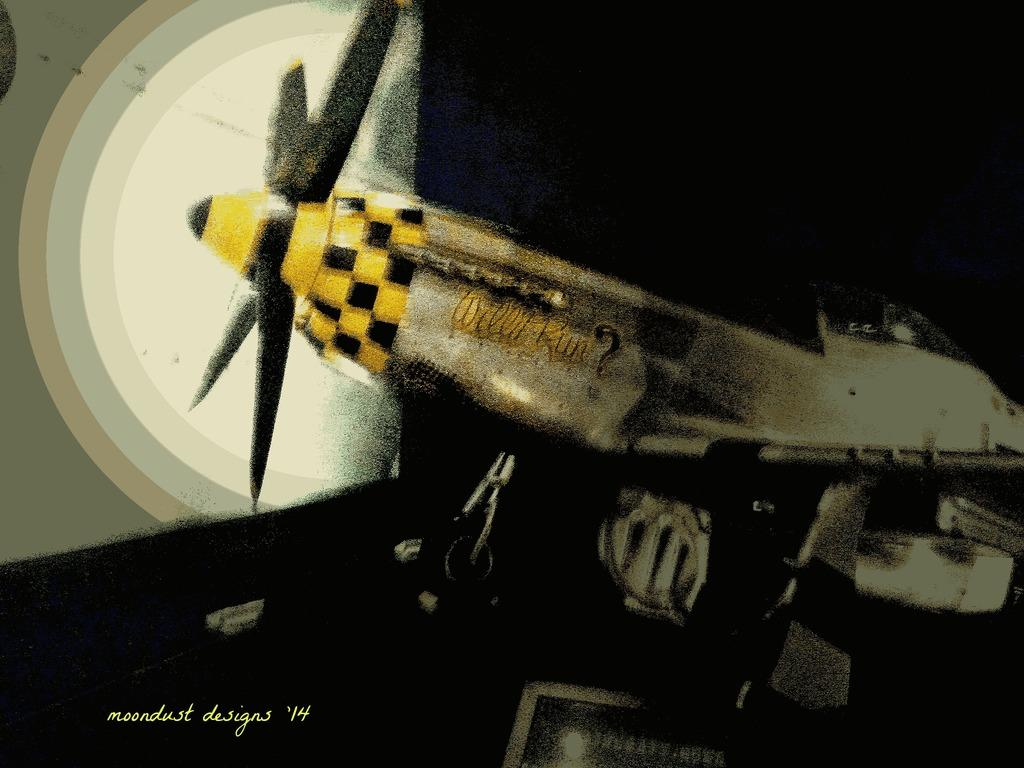What is featured on the poster in the image? There is a poster in the image, and it depicts a flying jet. What else can be seen on the poster besides the jet? There is text on the poster. Where is the prison located in the image? There is no prison present in the image. What type of humor can be seen in the image? There is no humor depicted in the image; it features a poster with a flying jet and text. 